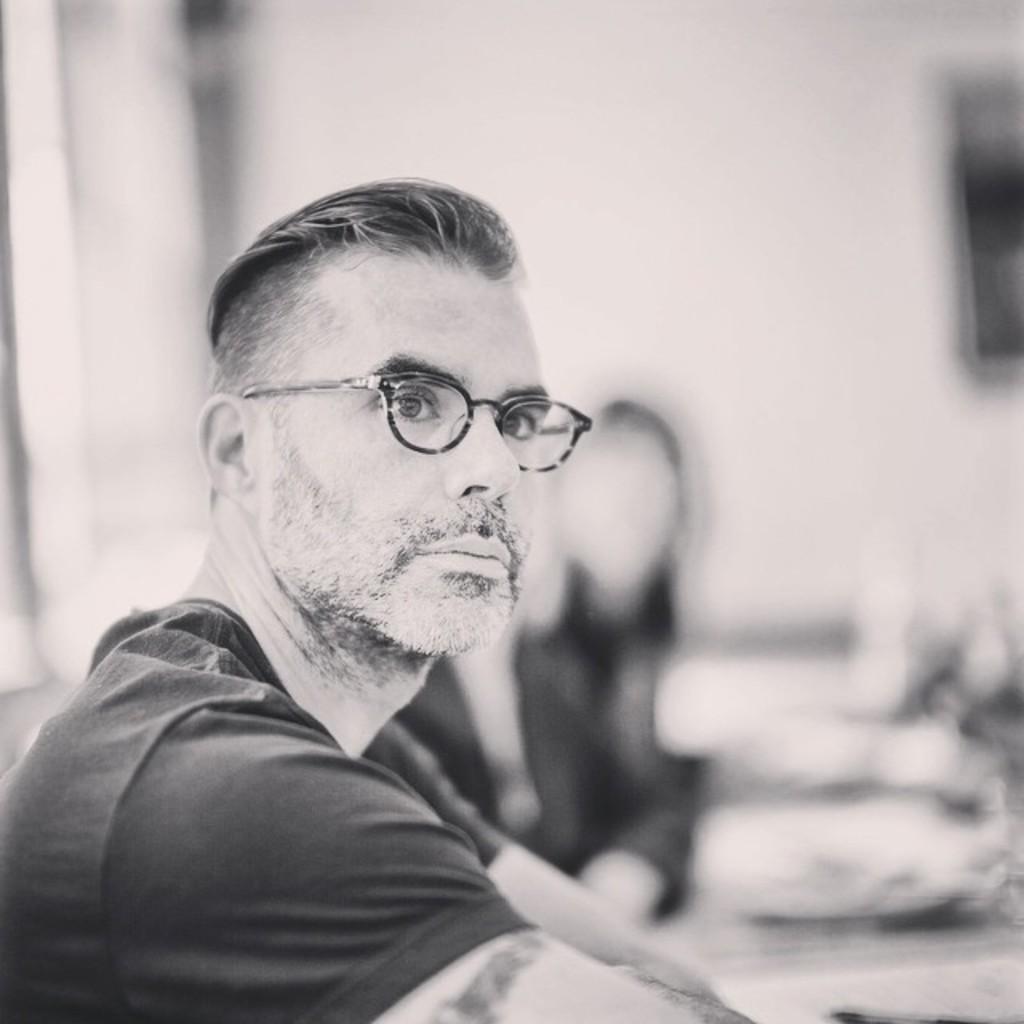Can you describe this image briefly? This is a black and white picture we can see people are sitting, among them one is wearing spectacles and the background is blurred. 